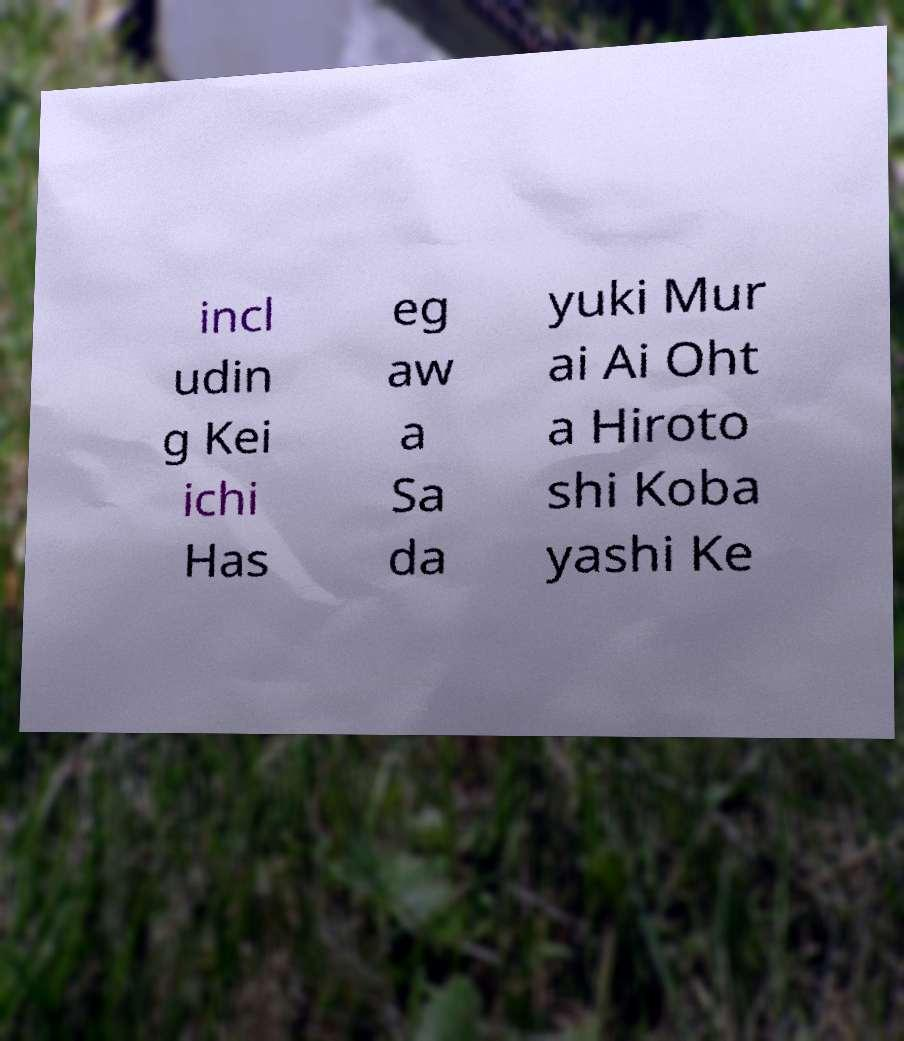What messages or text are displayed in this image? I need them in a readable, typed format. incl udin g Kei ichi Has eg aw a Sa da yuki Mur ai Ai Oht a Hiroto shi Koba yashi Ke 